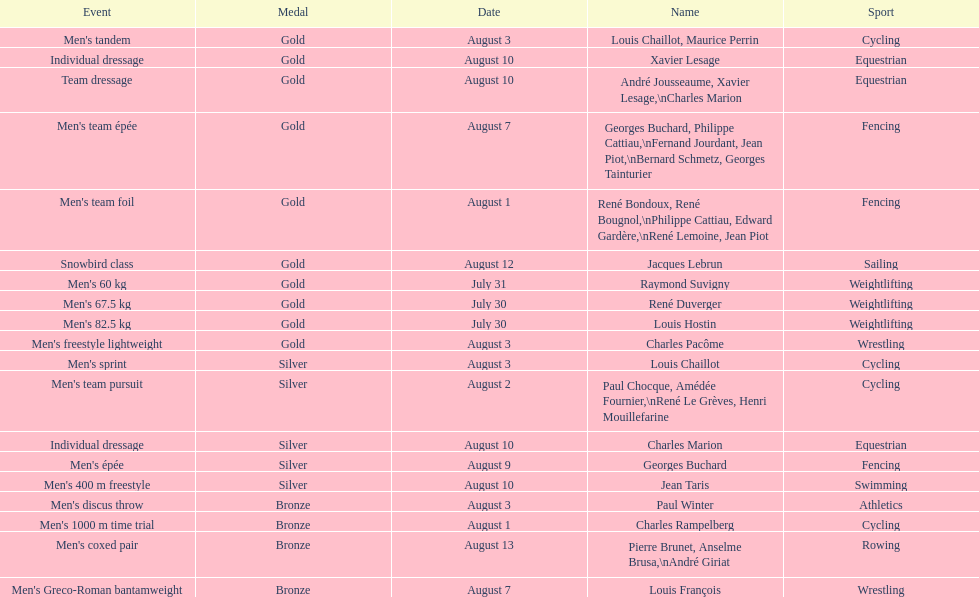How many medals were won after august 3? 9. 